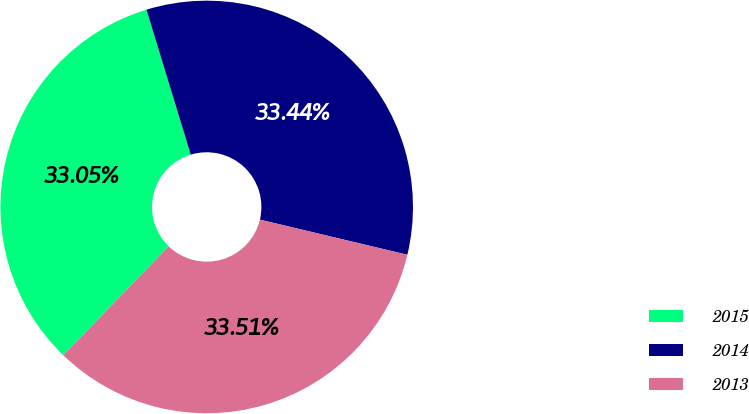Convert chart. <chart><loc_0><loc_0><loc_500><loc_500><pie_chart><fcel>2015<fcel>2014<fcel>2013<nl><fcel>33.05%<fcel>33.44%<fcel>33.51%<nl></chart> 